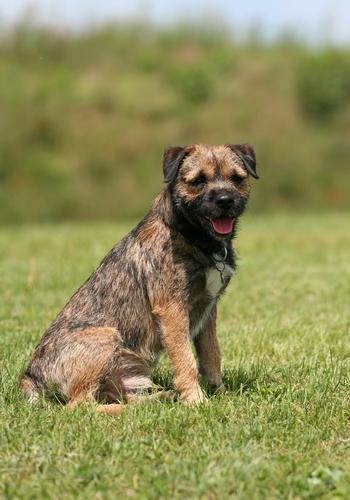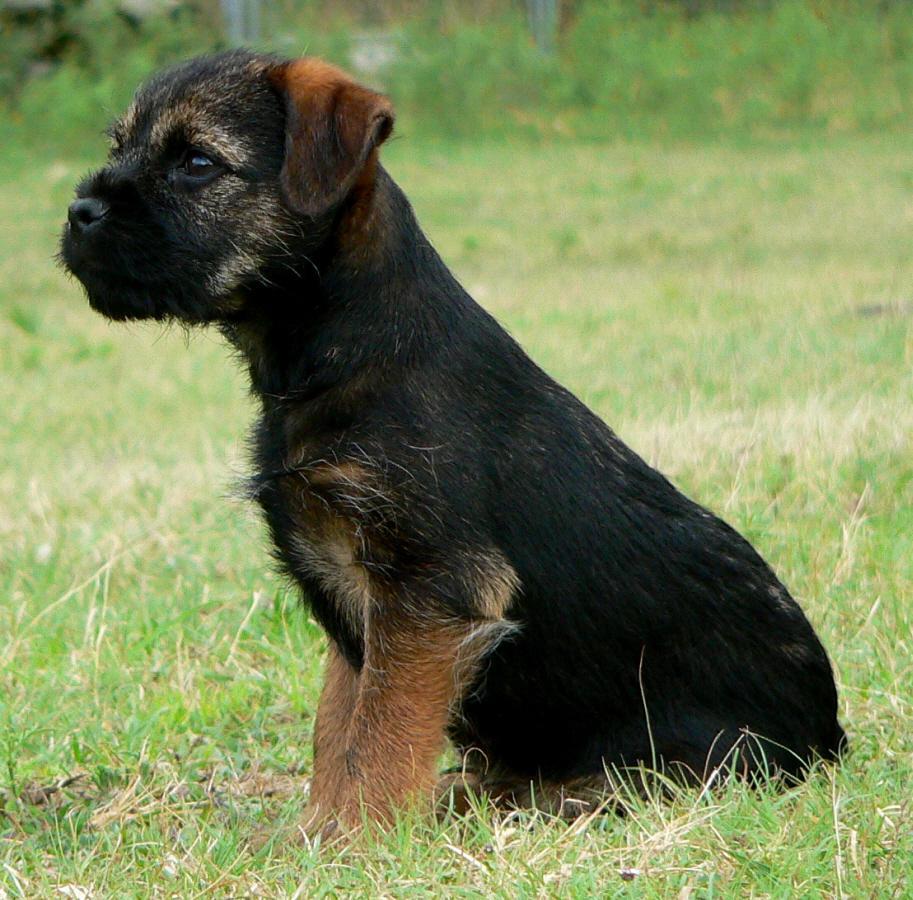The first image is the image on the left, the second image is the image on the right. Considering the images on both sides, is "There are at least two dogs lying on a wood bench." valid? Answer yes or no. No. 